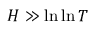Convert formula to latex. <formula><loc_0><loc_0><loc_500><loc_500>H \gg \ln \ln T</formula> 